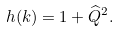<formula> <loc_0><loc_0><loc_500><loc_500>h ( k ) = { 1 + \widehat { Q } ^ { 2 } } .</formula> 